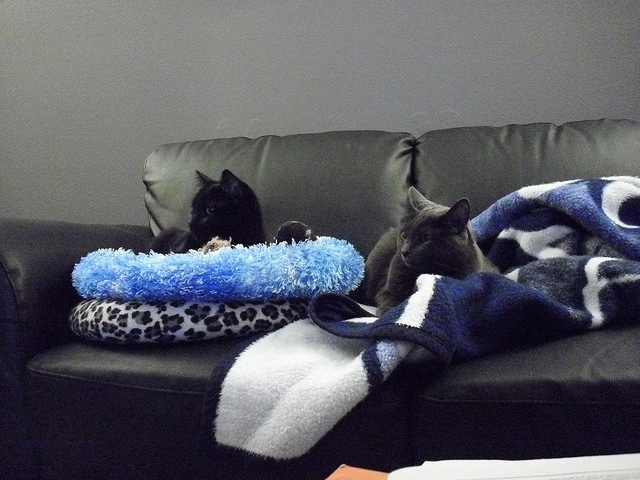Describe the objects in this image and their specific colors. I can see couch in gray and black tones, cat in gray, black, and darkgray tones, and cat in gray, black, and lightgray tones in this image. 